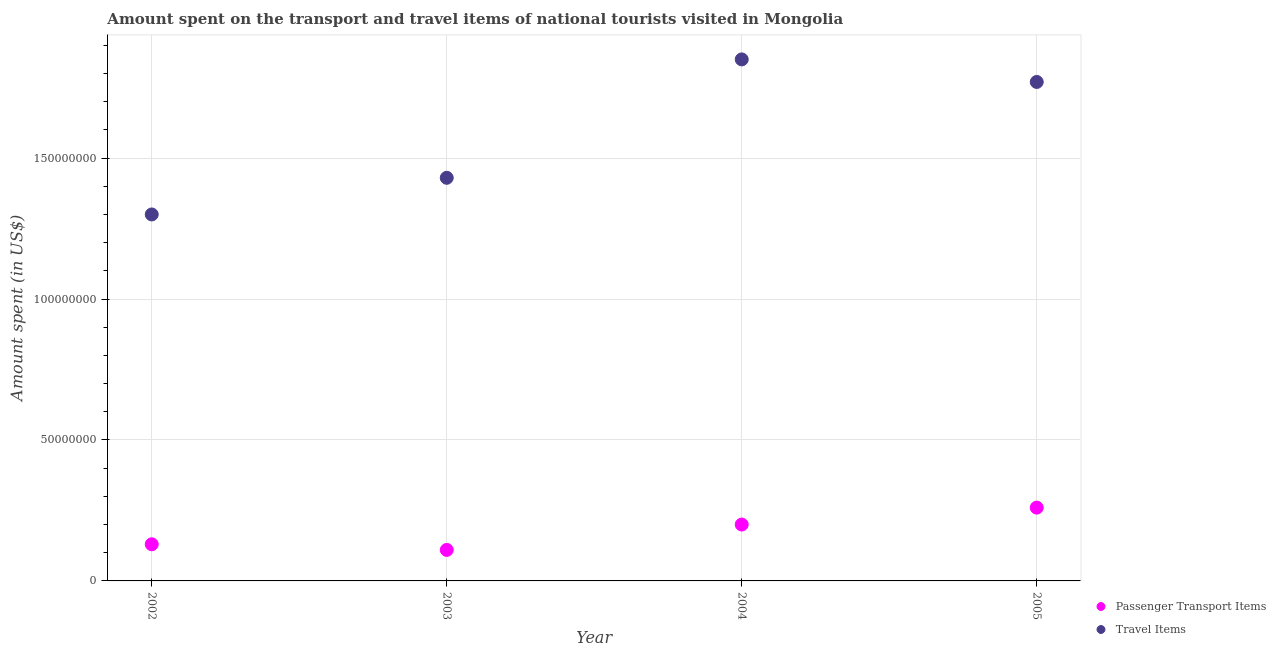How many different coloured dotlines are there?
Offer a terse response. 2. What is the amount spent on passenger transport items in 2004?
Provide a succinct answer. 2.00e+07. Across all years, what is the maximum amount spent on passenger transport items?
Keep it short and to the point. 2.60e+07. Across all years, what is the minimum amount spent on passenger transport items?
Provide a succinct answer. 1.10e+07. In which year was the amount spent on passenger transport items minimum?
Keep it short and to the point. 2003. What is the total amount spent in travel items in the graph?
Make the answer very short. 6.35e+08. What is the difference between the amount spent on passenger transport items in 2003 and that in 2005?
Keep it short and to the point. -1.50e+07. What is the difference between the amount spent in travel items in 2003 and the amount spent on passenger transport items in 2002?
Keep it short and to the point. 1.30e+08. What is the average amount spent in travel items per year?
Offer a terse response. 1.59e+08. In the year 2003, what is the difference between the amount spent on passenger transport items and amount spent in travel items?
Provide a short and direct response. -1.32e+08. Is the amount spent on passenger transport items in 2002 less than that in 2004?
Make the answer very short. Yes. What is the difference between the highest and the lowest amount spent on passenger transport items?
Provide a succinct answer. 1.50e+07. Is the sum of the amount spent on passenger transport items in 2002 and 2003 greater than the maximum amount spent in travel items across all years?
Offer a terse response. No. Is the amount spent on passenger transport items strictly greater than the amount spent in travel items over the years?
Provide a succinct answer. No. Are the values on the major ticks of Y-axis written in scientific E-notation?
Your response must be concise. No. Where does the legend appear in the graph?
Offer a very short reply. Bottom right. How many legend labels are there?
Keep it short and to the point. 2. How are the legend labels stacked?
Ensure brevity in your answer.  Vertical. What is the title of the graph?
Offer a terse response. Amount spent on the transport and travel items of national tourists visited in Mongolia. Does "From production" appear as one of the legend labels in the graph?
Your answer should be compact. No. What is the label or title of the X-axis?
Give a very brief answer. Year. What is the label or title of the Y-axis?
Provide a short and direct response. Amount spent (in US$). What is the Amount spent (in US$) in Passenger Transport Items in 2002?
Your response must be concise. 1.30e+07. What is the Amount spent (in US$) of Travel Items in 2002?
Your response must be concise. 1.30e+08. What is the Amount spent (in US$) of Passenger Transport Items in 2003?
Your answer should be compact. 1.10e+07. What is the Amount spent (in US$) in Travel Items in 2003?
Your response must be concise. 1.43e+08. What is the Amount spent (in US$) of Travel Items in 2004?
Make the answer very short. 1.85e+08. What is the Amount spent (in US$) of Passenger Transport Items in 2005?
Keep it short and to the point. 2.60e+07. What is the Amount spent (in US$) of Travel Items in 2005?
Your answer should be very brief. 1.77e+08. Across all years, what is the maximum Amount spent (in US$) in Passenger Transport Items?
Offer a very short reply. 2.60e+07. Across all years, what is the maximum Amount spent (in US$) in Travel Items?
Your answer should be compact. 1.85e+08. Across all years, what is the minimum Amount spent (in US$) of Passenger Transport Items?
Give a very brief answer. 1.10e+07. Across all years, what is the minimum Amount spent (in US$) of Travel Items?
Your answer should be compact. 1.30e+08. What is the total Amount spent (in US$) of Passenger Transport Items in the graph?
Give a very brief answer. 7.00e+07. What is the total Amount spent (in US$) of Travel Items in the graph?
Provide a short and direct response. 6.35e+08. What is the difference between the Amount spent (in US$) of Travel Items in 2002 and that in 2003?
Make the answer very short. -1.30e+07. What is the difference between the Amount spent (in US$) in Passenger Transport Items in 2002 and that in 2004?
Offer a very short reply. -7.00e+06. What is the difference between the Amount spent (in US$) in Travel Items in 2002 and that in 2004?
Offer a terse response. -5.50e+07. What is the difference between the Amount spent (in US$) in Passenger Transport Items in 2002 and that in 2005?
Offer a very short reply. -1.30e+07. What is the difference between the Amount spent (in US$) in Travel Items in 2002 and that in 2005?
Your answer should be very brief. -4.70e+07. What is the difference between the Amount spent (in US$) in Passenger Transport Items in 2003 and that in 2004?
Your response must be concise. -9.00e+06. What is the difference between the Amount spent (in US$) in Travel Items in 2003 and that in 2004?
Your response must be concise. -4.20e+07. What is the difference between the Amount spent (in US$) of Passenger Transport Items in 2003 and that in 2005?
Your answer should be compact. -1.50e+07. What is the difference between the Amount spent (in US$) in Travel Items in 2003 and that in 2005?
Provide a short and direct response. -3.40e+07. What is the difference between the Amount spent (in US$) in Passenger Transport Items in 2004 and that in 2005?
Provide a succinct answer. -6.00e+06. What is the difference between the Amount spent (in US$) in Travel Items in 2004 and that in 2005?
Offer a very short reply. 8.00e+06. What is the difference between the Amount spent (in US$) of Passenger Transport Items in 2002 and the Amount spent (in US$) of Travel Items in 2003?
Give a very brief answer. -1.30e+08. What is the difference between the Amount spent (in US$) of Passenger Transport Items in 2002 and the Amount spent (in US$) of Travel Items in 2004?
Your answer should be very brief. -1.72e+08. What is the difference between the Amount spent (in US$) of Passenger Transport Items in 2002 and the Amount spent (in US$) of Travel Items in 2005?
Your answer should be compact. -1.64e+08. What is the difference between the Amount spent (in US$) in Passenger Transport Items in 2003 and the Amount spent (in US$) in Travel Items in 2004?
Provide a short and direct response. -1.74e+08. What is the difference between the Amount spent (in US$) in Passenger Transport Items in 2003 and the Amount spent (in US$) in Travel Items in 2005?
Keep it short and to the point. -1.66e+08. What is the difference between the Amount spent (in US$) in Passenger Transport Items in 2004 and the Amount spent (in US$) in Travel Items in 2005?
Keep it short and to the point. -1.57e+08. What is the average Amount spent (in US$) in Passenger Transport Items per year?
Provide a short and direct response. 1.75e+07. What is the average Amount spent (in US$) in Travel Items per year?
Provide a succinct answer. 1.59e+08. In the year 2002, what is the difference between the Amount spent (in US$) of Passenger Transport Items and Amount spent (in US$) of Travel Items?
Give a very brief answer. -1.17e+08. In the year 2003, what is the difference between the Amount spent (in US$) in Passenger Transport Items and Amount spent (in US$) in Travel Items?
Provide a succinct answer. -1.32e+08. In the year 2004, what is the difference between the Amount spent (in US$) in Passenger Transport Items and Amount spent (in US$) in Travel Items?
Provide a succinct answer. -1.65e+08. In the year 2005, what is the difference between the Amount spent (in US$) of Passenger Transport Items and Amount spent (in US$) of Travel Items?
Keep it short and to the point. -1.51e+08. What is the ratio of the Amount spent (in US$) of Passenger Transport Items in 2002 to that in 2003?
Your answer should be compact. 1.18. What is the ratio of the Amount spent (in US$) of Travel Items in 2002 to that in 2003?
Keep it short and to the point. 0.91. What is the ratio of the Amount spent (in US$) in Passenger Transport Items in 2002 to that in 2004?
Your answer should be very brief. 0.65. What is the ratio of the Amount spent (in US$) of Travel Items in 2002 to that in 2004?
Provide a short and direct response. 0.7. What is the ratio of the Amount spent (in US$) of Travel Items in 2002 to that in 2005?
Offer a terse response. 0.73. What is the ratio of the Amount spent (in US$) in Passenger Transport Items in 2003 to that in 2004?
Offer a terse response. 0.55. What is the ratio of the Amount spent (in US$) of Travel Items in 2003 to that in 2004?
Offer a very short reply. 0.77. What is the ratio of the Amount spent (in US$) in Passenger Transport Items in 2003 to that in 2005?
Keep it short and to the point. 0.42. What is the ratio of the Amount spent (in US$) in Travel Items in 2003 to that in 2005?
Offer a very short reply. 0.81. What is the ratio of the Amount spent (in US$) in Passenger Transport Items in 2004 to that in 2005?
Your answer should be very brief. 0.77. What is the ratio of the Amount spent (in US$) in Travel Items in 2004 to that in 2005?
Make the answer very short. 1.05. What is the difference between the highest and the second highest Amount spent (in US$) in Travel Items?
Provide a succinct answer. 8.00e+06. What is the difference between the highest and the lowest Amount spent (in US$) in Passenger Transport Items?
Your response must be concise. 1.50e+07. What is the difference between the highest and the lowest Amount spent (in US$) of Travel Items?
Provide a succinct answer. 5.50e+07. 